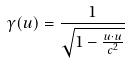Convert formula to latex. <formula><loc_0><loc_0><loc_500><loc_500>\gamma ( u ) = \frac { 1 } { \sqrt { 1 - \frac { u \cdot u } { c ^ { 2 } } } }</formula> 